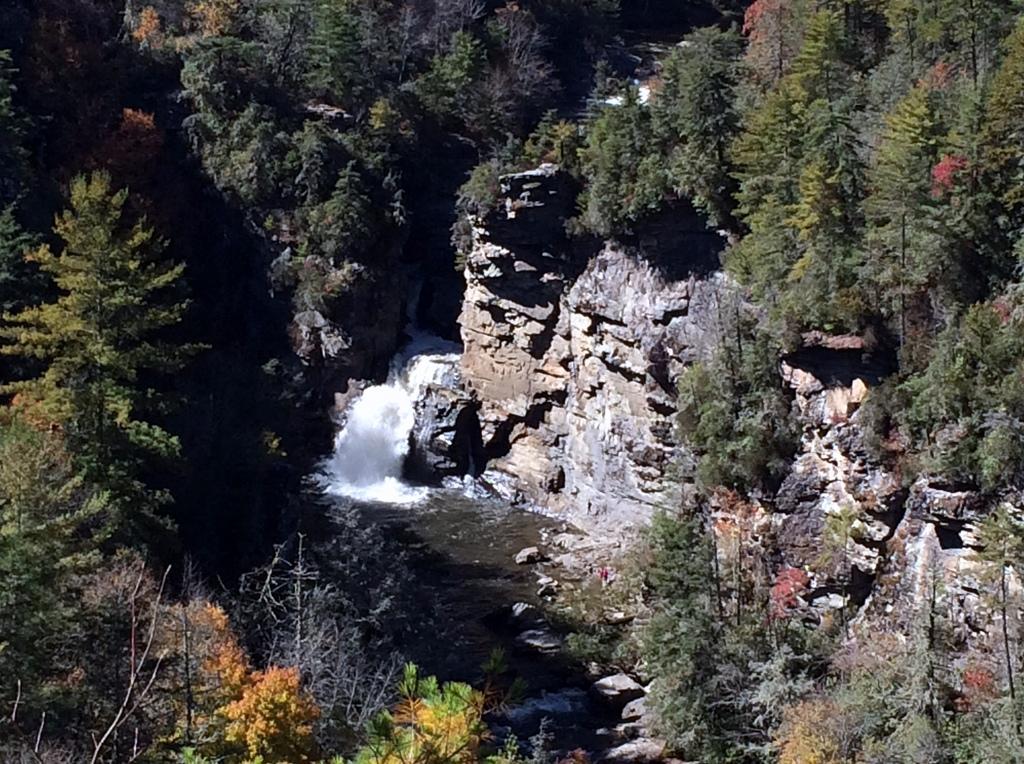Describe this image in one or two sentences. In this picture we can see water, few rocks and trees. 